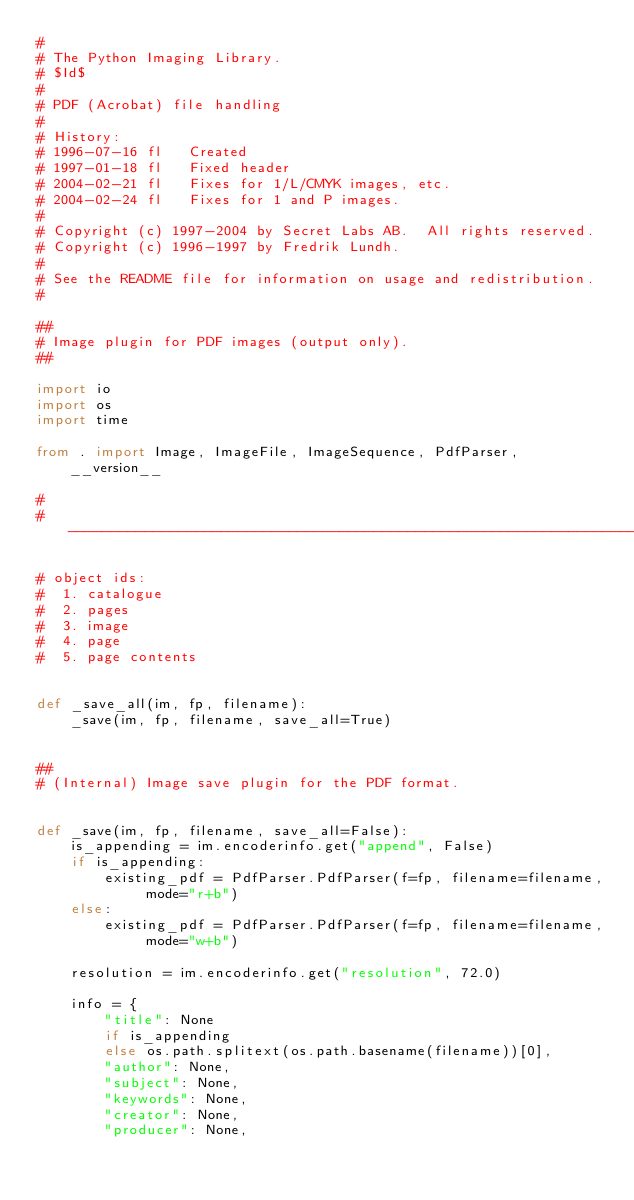<code> <loc_0><loc_0><loc_500><loc_500><_Python_>#
# The Python Imaging Library.
# $Id$
#
# PDF (Acrobat) file handling
#
# History:
# 1996-07-16 fl   Created
# 1997-01-18 fl   Fixed header
# 2004-02-21 fl   Fixes for 1/L/CMYK images, etc.
# 2004-02-24 fl   Fixes for 1 and P images.
#
# Copyright (c) 1997-2004 by Secret Labs AB.  All rights reserved.
# Copyright (c) 1996-1997 by Fredrik Lundh.
#
# See the README file for information on usage and redistribution.
#

##
# Image plugin for PDF images (output only).
##

import io
import os
import time

from . import Image, ImageFile, ImageSequence, PdfParser, __version__

#
# --------------------------------------------------------------------

# object ids:
#  1. catalogue
#  2. pages
#  3. image
#  4. page
#  5. page contents


def _save_all(im, fp, filename):
    _save(im, fp, filename, save_all=True)


##
# (Internal) Image save plugin for the PDF format.


def _save(im, fp, filename, save_all=False):
    is_appending = im.encoderinfo.get("append", False)
    if is_appending:
        existing_pdf = PdfParser.PdfParser(f=fp, filename=filename, mode="r+b")
    else:
        existing_pdf = PdfParser.PdfParser(f=fp, filename=filename, mode="w+b")

    resolution = im.encoderinfo.get("resolution", 72.0)

    info = {
        "title": None
        if is_appending
        else os.path.splitext(os.path.basename(filename))[0],
        "author": None,
        "subject": None,
        "keywords": None,
        "creator": None,
        "producer": None,</code> 